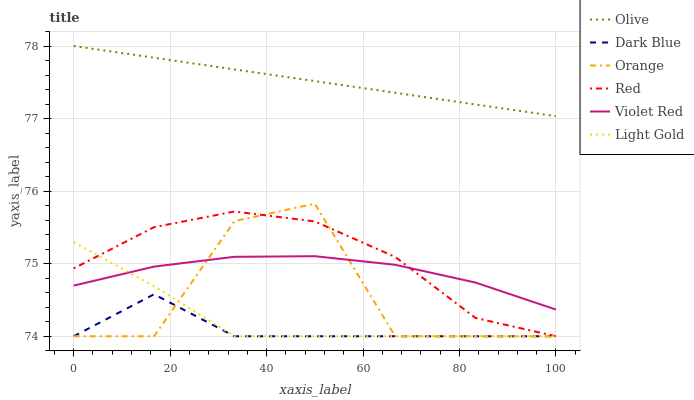Does Dark Blue have the minimum area under the curve?
Answer yes or no. Yes. Does Olive have the maximum area under the curve?
Answer yes or no. Yes. Does Olive have the minimum area under the curve?
Answer yes or no. No. Does Dark Blue have the maximum area under the curve?
Answer yes or no. No. Is Olive the smoothest?
Answer yes or no. Yes. Is Orange the roughest?
Answer yes or no. Yes. Is Dark Blue the smoothest?
Answer yes or no. No. Is Dark Blue the roughest?
Answer yes or no. No. Does Dark Blue have the lowest value?
Answer yes or no. Yes. Does Olive have the lowest value?
Answer yes or no. No. Does Olive have the highest value?
Answer yes or no. Yes. Does Dark Blue have the highest value?
Answer yes or no. No. Is Red less than Olive?
Answer yes or no. Yes. Is Violet Red greater than Dark Blue?
Answer yes or no. Yes. Does Light Gold intersect Orange?
Answer yes or no. Yes. Is Light Gold less than Orange?
Answer yes or no. No. Is Light Gold greater than Orange?
Answer yes or no. No. Does Red intersect Olive?
Answer yes or no. No. 